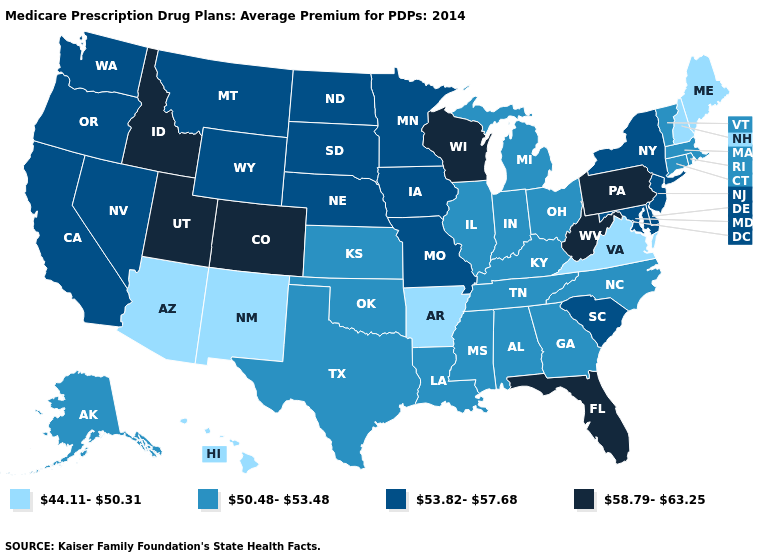Which states have the highest value in the USA?
Give a very brief answer. Colorado, Florida, Idaho, Pennsylvania, Utah, Wisconsin, West Virginia. Which states have the lowest value in the USA?
Keep it brief. Arkansas, Arizona, Hawaii, Maine, New Hampshire, New Mexico, Virginia. Does Missouri have the lowest value in the MidWest?
Concise answer only. No. Name the states that have a value in the range 58.79-63.25?
Short answer required. Colorado, Florida, Idaho, Pennsylvania, Utah, Wisconsin, West Virginia. Does Maryland have the lowest value in the South?
Be succinct. No. Does Idaho have the lowest value in the USA?
Keep it brief. No. What is the value of Maine?
Write a very short answer. 44.11-50.31. What is the value of Tennessee?
Give a very brief answer. 50.48-53.48. Name the states that have a value in the range 50.48-53.48?
Concise answer only. Alaska, Alabama, Connecticut, Georgia, Illinois, Indiana, Kansas, Kentucky, Louisiana, Massachusetts, Michigan, Mississippi, North Carolina, Ohio, Oklahoma, Rhode Island, Tennessee, Texas, Vermont. Which states have the lowest value in the MidWest?
Quick response, please. Illinois, Indiana, Kansas, Michigan, Ohio. Does Oklahoma have the lowest value in the South?
Be succinct. No. Among the states that border Maryland , does Pennsylvania have the highest value?
Answer briefly. Yes. Does the map have missing data?
Give a very brief answer. No. Name the states that have a value in the range 50.48-53.48?
Short answer required. Alaska, Alabama, Connecticut, Georgia, Illinois, Indiana, Kansas, Kentucky, Louisiana, Massachusetts, Michigan, Mississippi, North Carolina, Ohio, Oklahoma, Rhode Island, Tennessee, Texas, Vermont. Does Wisconsin have the lowest value in the USA?
Give a very brief answer. No. 